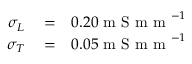<formula> <loc_0><loc_0><loc_500><loc_500>\begin{array} { r l r } { \sigma _ { L } } & = } & { 0 . 2 0 m S m m ^ { - 1 } } \\ { \sigma _ { T } } & = } & { 0 . 0 5 m S m m ^ { - 1 } } \end{array}</formula> 